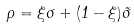<formula> <loc_0><loc_0><loc_500><loc_500>\rho = \xi \sigma + ( 1 - \xi ) \tilde { \sigma }</formula> 